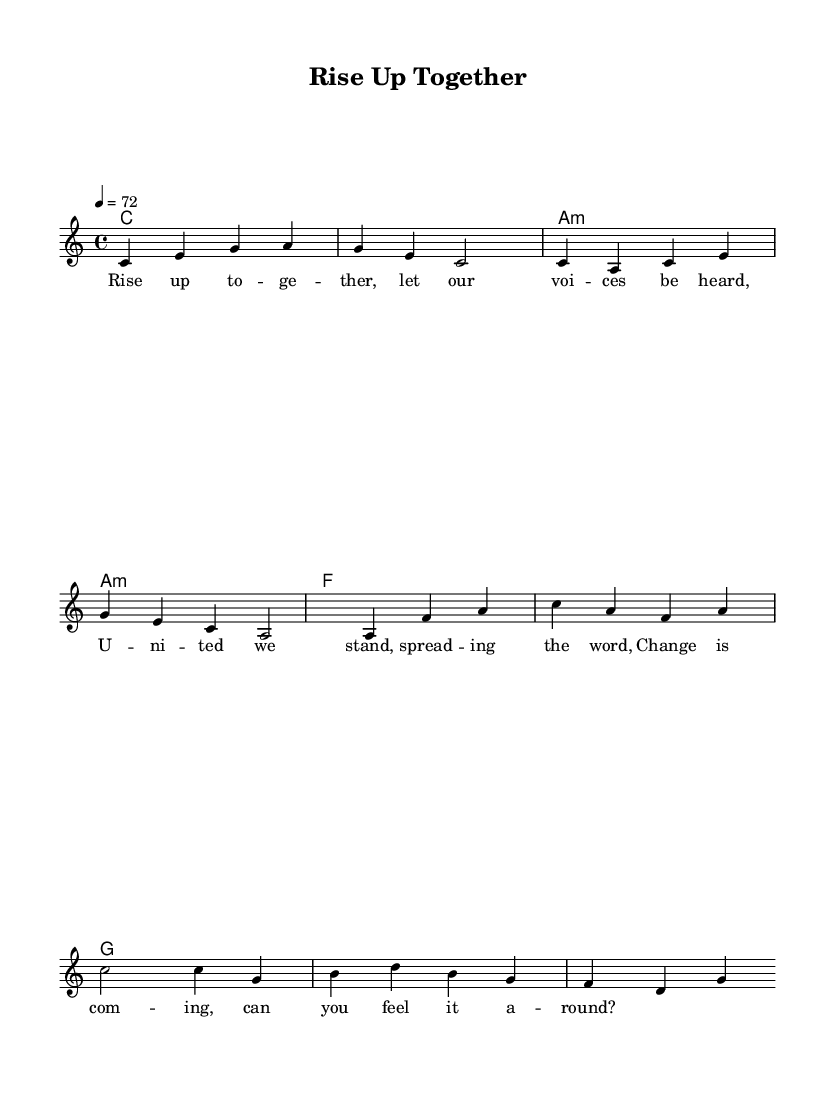What is the key signature of this music? The key signature is indicated at the beginning of the staff and shows C major, which has no sharps or flats.
Answer: C major What is the time signature of this music? The time signature is found at the start of the piece, indicating how the beats are grouped together per measure. Here, it shows 4/4, meaning four beats per measure.
Answer: 4/4 What is the tempo marking of this music? The tempo marking is located in the header of the score, specifying the speed of the piece in beats per minute. It shows that the tempo is set to 72 beats per minute.
Answer: 72 How many measures are present in the melody? By counting the bars in the melody line, we see that there are a total of eight measures represented.
Answer: 8 What is the first chord played in this piece? Looking at the chord names under the melody, the very first chord shown is C, which appears at the start of the first measure.
Answer: C What lyrics correspond to the first measure? To identify the lyrics for the first measure, we can look directly under the melody line, where it shows "Rise up to -- ge -- ther," which belongs to the first bar.
Answer: Rise up to -- ge -- ther What social theme is emphasized in the song's lyrics? The lyrics’ content calls for unity and change, indicating the song’s focus on community empowerment and social change. Therefore, this theme is prominent throughout.
Answer: Community empowerment 